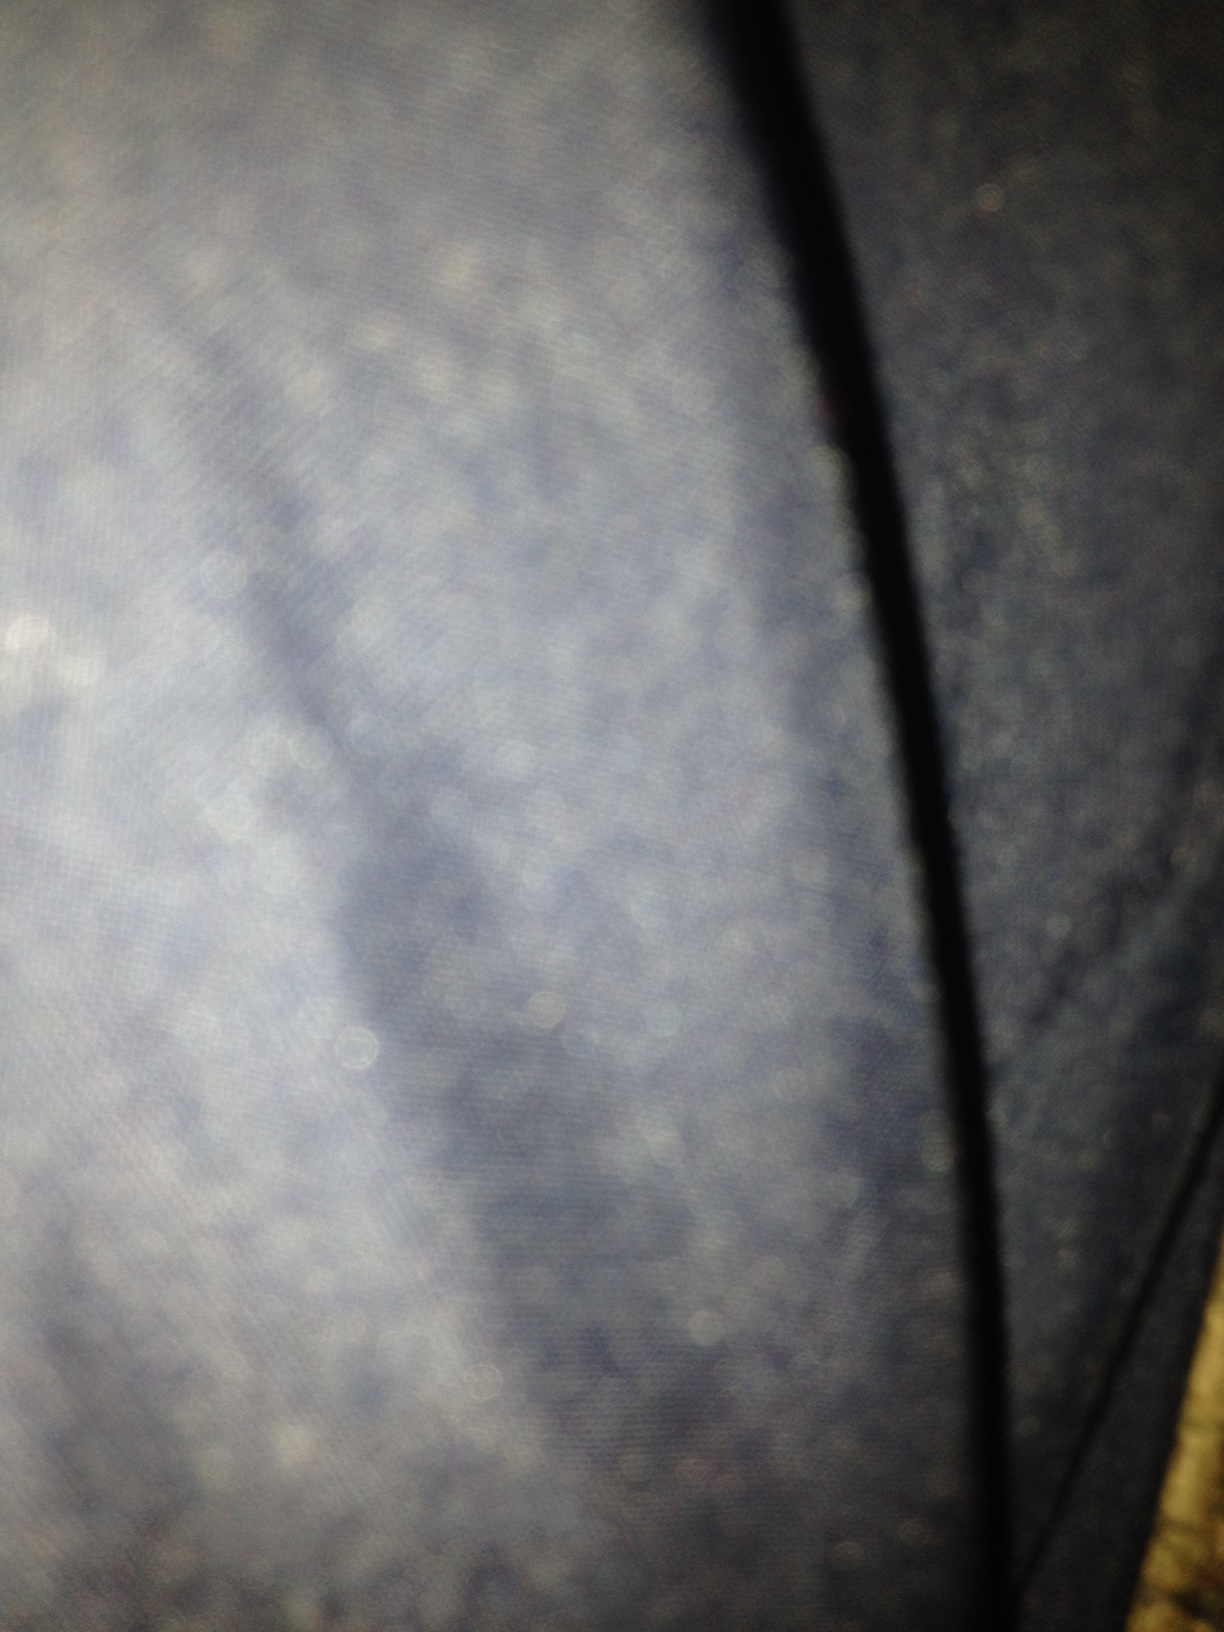Can you describe any details you can make out in this image? The image is predominantly blurry with a textured appearance that might suggest fabric, perhaps a close-up of denim. There are no discernible features due to the lack of clarity. 